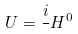Convert formula to latex. <formula><loc_0><loc_0><loc_500><loc_500>U = \frac { i } { } H ^ { 0 }</formula> 